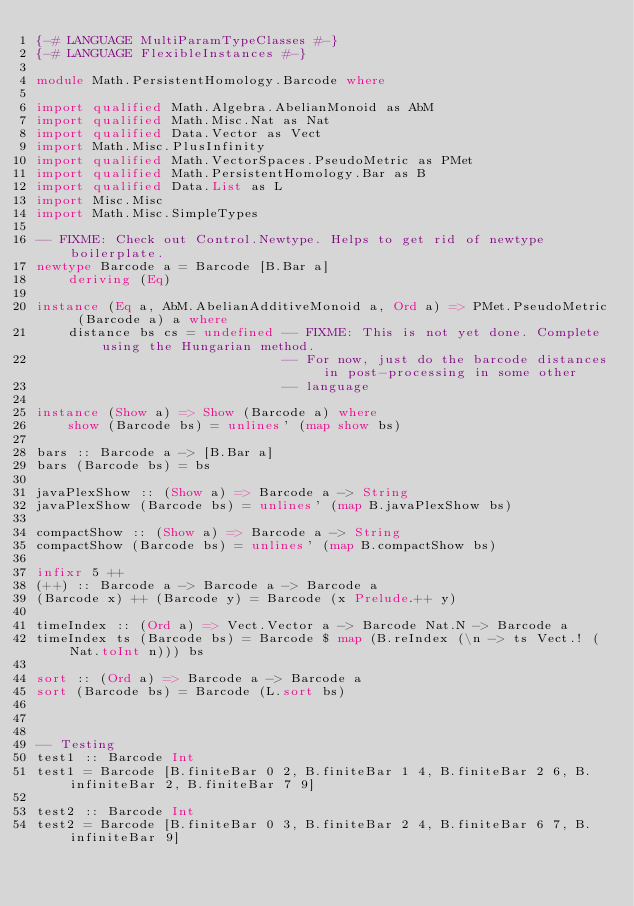<code> <loc_0><loc_0><loc_500><loc_500><_Haskell_>{-# LANGUAGE MultiParamTypeClasses #-}
{-# LANGUAGE FlexibleInstances #-}

module Math.PersistentHomology.Barcode where

import qualified Math.Algebra.AbelianMonoid as AbM
import qualified Math.Misc.Nat as Nat
import qualified Data.Vector as Vect
import Math.Misc.PlusInfinity
import qualified Math.VectorSpaces.PseudoMetric as PMet
import qualified Math.PersistentHomology.Bar as B
import qualified Data.List as L
import Misc.Misc
import Math.Misc.SimpleTypes

-- FIXME: Check out Control.Newtype. Helps to get rid of newtype boilerplate.
newtype Barcode a = Barcode [B.Bar a]
    deriving (Eq)

instance (Eq a, AbM.AbelianAdditiveMonoid a, Ord a) => PMet.PseudoMetric (Barcode a) a where
    distance bs cs = undefined -- FIXME: This is not yet done. Complete using the Hungarian method.
                               -- For now, just do the barcode distances in post-processing in some other
                               -- language

instance (Show a) => Show (Barcode a) where
    show (Barcode bs) = unlines' (map show bs)

bars :: Barcode a -> [B.Bar a]
bars (Barcode bs) = bs

javaPlexShow :: (Show a) => Barcode a -> String
javaPlexShow (Barcode bs) = unlines' (map B.javaPlexShow bs)

compactShow :: (Show a) => Barcode a -> String
compactShow (Barcode bs) = unlines' (map B.compactShow bs)

infixr 5 ++
(++) :: Barcode a -> Barcode a -> Barcode a
(Barcode x) ++ (Barcode y) = Barcode (x Prelude.++ y)

timeIndex :: (Ord a) => Vect.Vector a -> Barcode Nat.N -> Barcode a
timeIndex ts (Barcode bs) = Barcode $ map (B.reIndex (\n -> ts Vect.! (Nat.toInt n))) bs

sort :: (Ord a) => Barcode a -> Barcode a
sort (Barcode bs) = Barcode (L.sort bs)



-- Testing
test1 :: Barcode Int
test1 = Barcode [B.finiteBar 0 2, B.finiteBar 1 4, B.finiteBar 2 6, B.infiniteBar 2, B.finiteBar 7 9]

test2 :: Barcode Int
test2 = Barcode [B.finiteBar 0 3, B.finiteBar 2 4, B.finiteBar 6 7, B.infiniteBar 9]</code> 